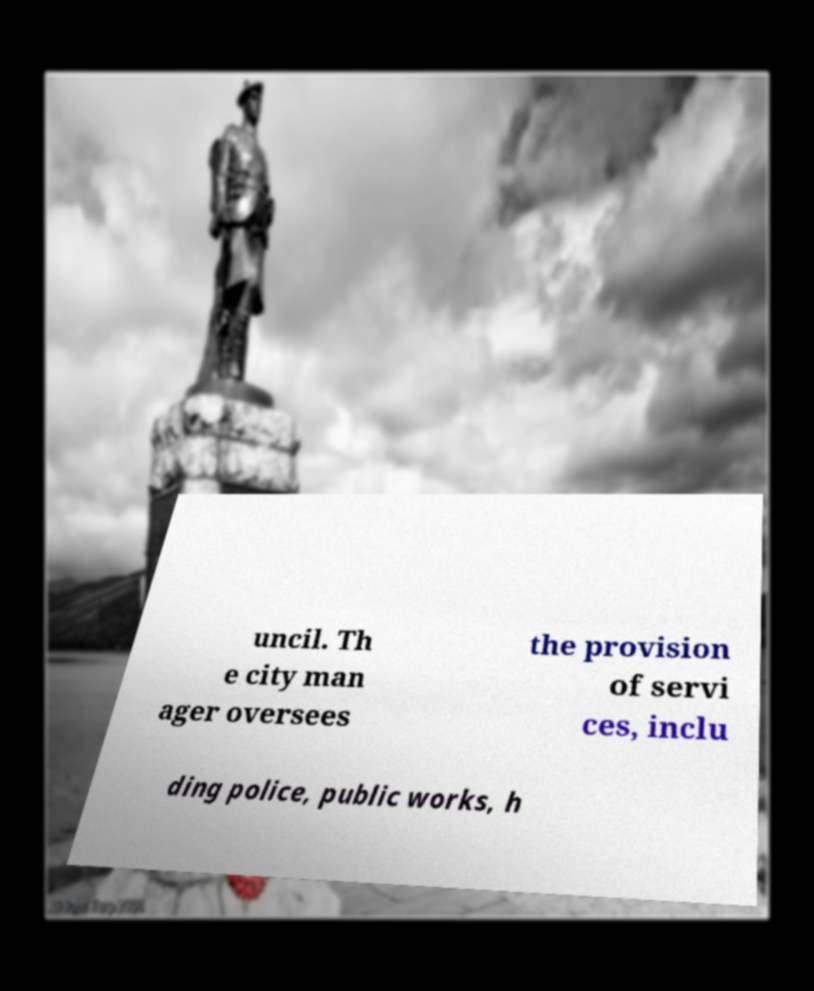Can you accurately transcribe the text from the provided image for me? uncil. Th e city man ager oversees the provision of servi ces, inclu ding police, public works, h 